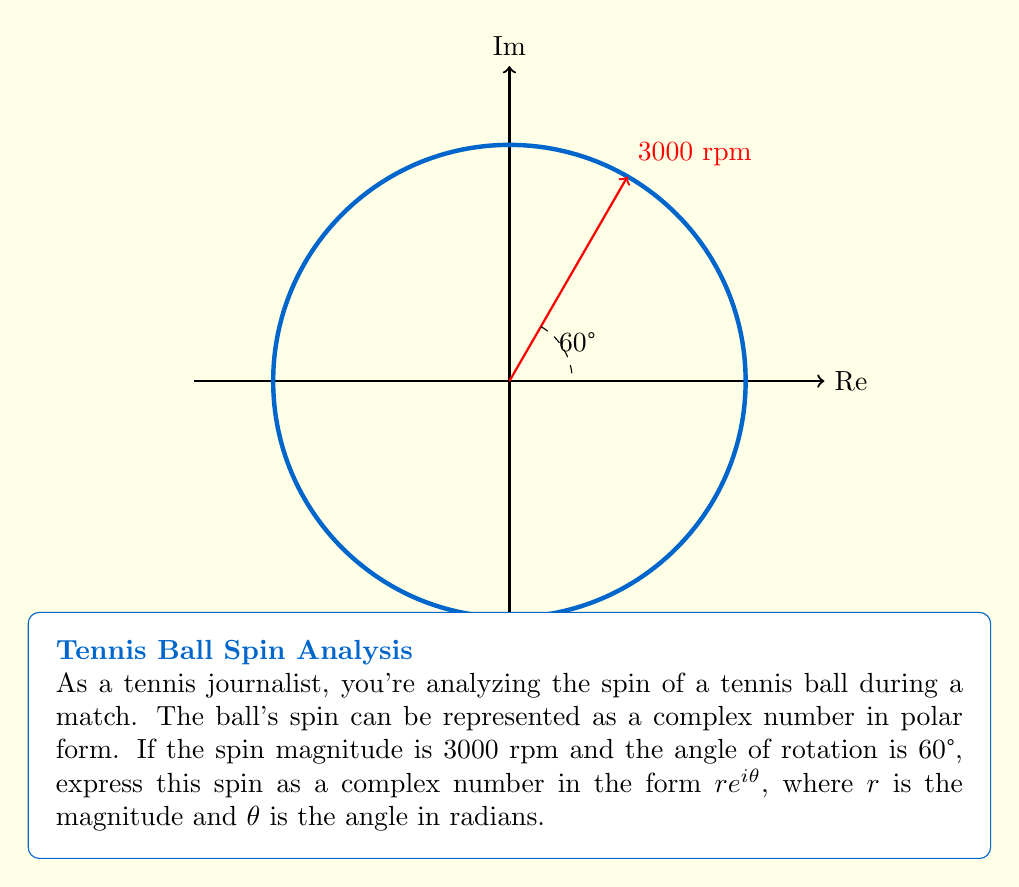Show me your answer to this math problem. To express the spin as a complex number in the form $re^{i\theta}$, we need to:

1. Identify the magnitude $r$:
   $r = 3000$ rpm

2. Convert the angle from degrees to radians:
   $\theta = 60° \times \frac{\pi}{180°} = \frac{\pi}{3}$ radians

3. Substitute these values into the polar form of a complex number:
   $z = re^{i\theta} = 3000e^{i\frac{\pi}{3}}$

This representation fully describes the spin of the tennis ball, where:
- 3000 represents the magnitude of the spin in rpm
- $e^{i\frac{\pi}{3}}$ represents the direction of the spin

Note: In tennis, this could represent a combination of topspin and sidespin, with the magnitude indicating the intensity of the spin and the angle indicating the ratio between topspin and sidespin.
Answer: $3000e^{i\frac{\pi}{3}}$ 